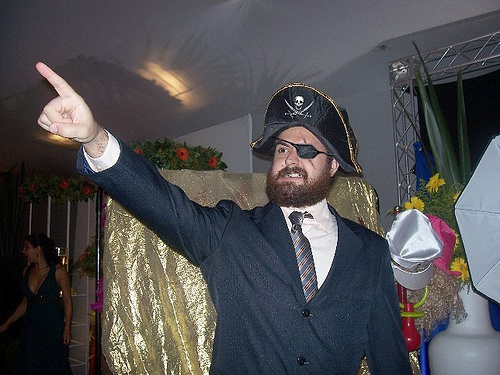Describe the objects in this image and their specific colors. I can see people in black, navy, gray, and darkblue tones, people in black, maroon, and gray tones, umbrella in black, darkgray, and lightblue tones, and tie in black, gray, and darkgray tones in this image. 